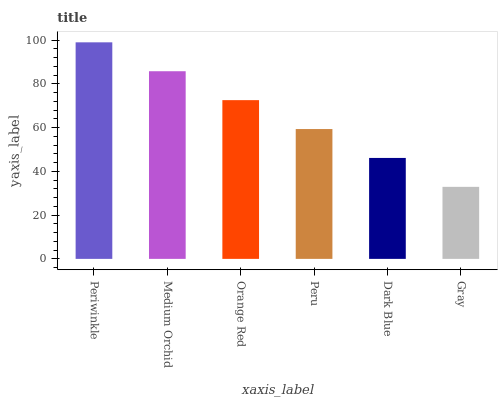Is Gray the minimum?
Answer yes or no. Yes. Is Periwinkle the maximum?
Answer yes or no. Yes. Is Medium Orchid the minimum?
Answer yes or no. No. Is Medium Orchid the maximum?
Answer yes or no. No. Is Periwinkle greater than Medium Orchid?
Answer yes or no. Yes. Is Medium Orchid less than Periwinkle?
Answer yes or no. Yes. Is Medium Orchid greater than Periwinkle?
Answer yes or no. No. Is Periwinkle less than Medium Orchid?
Answer yes or no. No. Is Orange Red the high median?
Answer yes or no. Yes. Is Peru the low median?
Answer yes or no. Yes. Is Dark Blue the high median?
Answer yes or no. No. Is Dark Blue the low median?
Answer yes or no. No. 